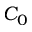<formula> <loc_0><loc_0><loc_500><loc_500>C _ { 0 }</formula> 